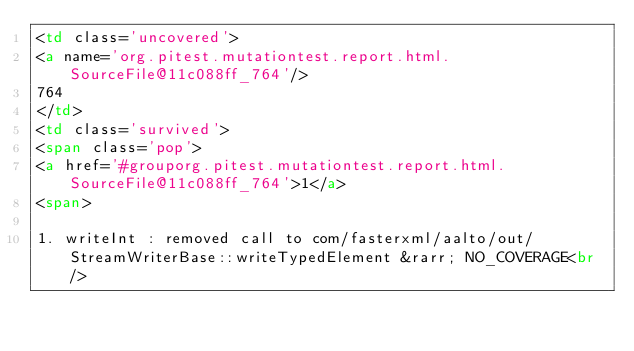Convert code to text. <code><loc_0><loc_0><loc_500><loc_500><_HTML_><td class='uncovered'>
<a name='org.pitest.mutationtest.report.html.SourceFile@11c088ff_764'/>
764
</td>
<td class='survived'>
<span class='pop'>
<a href='#grouporg.pitest.mutationtest.report.html.SourceFile@11c088ff_764'>1</a>
<span>

1. writeInt : removed call to com/fasterxml/aalto/out/StreamWriterBase::writeTypedElement &rarr; NO_COVERAGE<br/>
</code> 